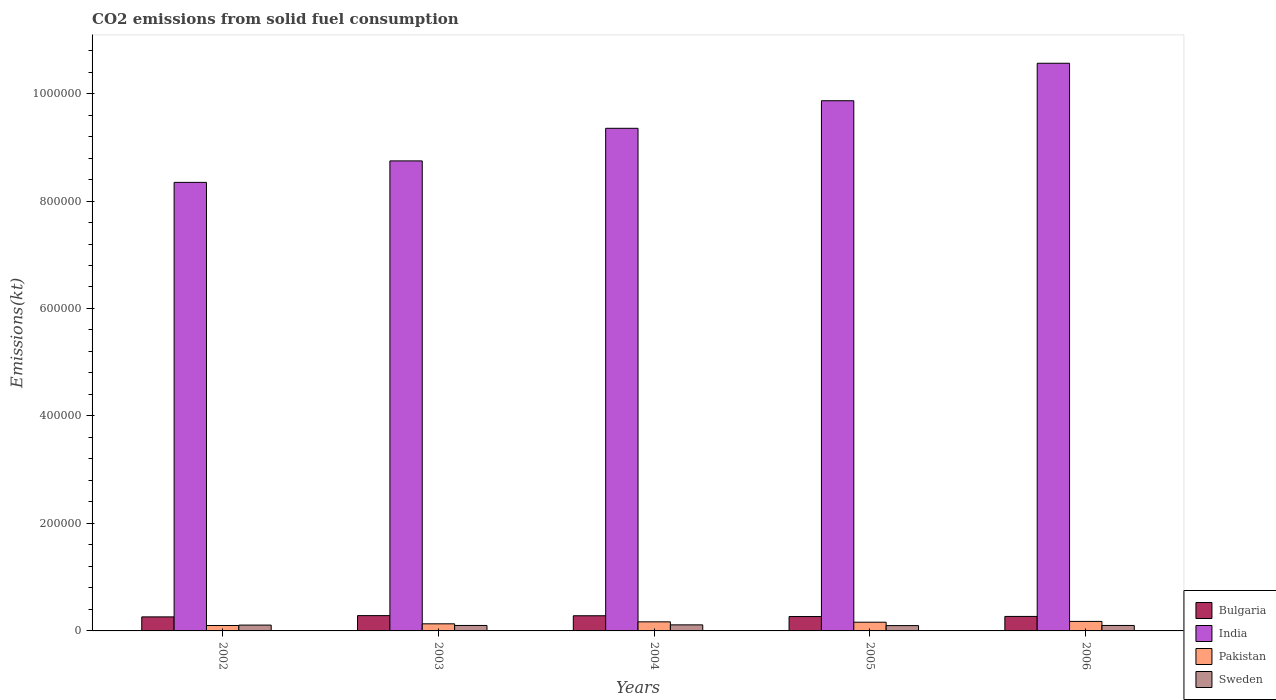How many groups of bars are there?
Make the answer very short. 5. Are the number of bars per tick equal to the number of legend labels?
Ensure brevity in your answer.  Yes. Are the number of bars on each tick of the X-axis equal?
Ensure brevity in your answer.  Yes. How many bars are there on the 4th tick from the left?
Your response must be concise. 4. What is the label of the 4th group of bars from the left?
Your answer should be very brief. 2005. In how many cases, is the number of bars for a given year not equal to the number of legend labels?
Ensure brevity in your answer.  0. What is the amount of CO2 emitted in Sweden in 2002?
Make the answer very short. 1.09e+04. Across all years, what is the maximum amount of CO2 emitted in Pakistan?
Offer a terse response. 1.77e+04. Across all years, what is the minimum amount of CO2 emitted in Pakistan?
Your answer should be compact. 1.01e+04. In which year was the amount of CO2 emitted in Sweden maximum?
Provide a short and direct response. 2004. In which year was the amount of CO2 emitted in India minimum?
Provide a short and direct response. 2002. What is the total amount of CO2 emitted in India in the graph?
Your answer should be compact. 4.69e+06. What is the difference between the amount of CO2 emitted in Sweden in 2005 and that in 2006?
Make the answer very short. -256.69. What is the difference between the amount of CO2 emitted in India in 2003 and the amount of CO2 emitted in Bulgaria in 2005?
Your response must be concise. 8.48e+05. What is the average amount of CO2 emitted in India per year?
Provide a short and direct response. 9.38e+05. In the year 2002, what is the difference between the amount of CO2 emitted in Pakistan and amount of CO2 emitted in Bulgaria?
Ensure brevity in your answer.  -1.60e+04. In how many years, is the amount of CO2 emitted in Pakistan greater than 920000 kt?
Your answer should be compact. 0. What is the ratio of the amount of CO2 emitted in India in 2004 to that in 2006?
Offer a terse response. 0.89. Is the amount of CO2 emitted in Sweden in 2002 less than that in 2003?
Your answer should be compact. No. Is the difference between the amount of CO2 emitted in Pakistan in 2003 and 2006 greater than the difference between the amount of CO2 emitted in Bulgaria in 2003 and 2006?
Provide a short and direct response. No. What is the difference between the highest and the second highest amount of CO2 emitted in Bulgaria?
Keep it short and to the point. 260.36. What is the difference between the highest and the lowest amount of CO2 emitted in Pakistan?
Your answer should be very brief. 7616.36. In how many years, is the amount of CO2 emitted in Bulgaria greater than the average amount of CO2 emitted in Bulgaria taken over all years?
Your answer should be compact. 2. What does the 1st bar from the right in 2006 represents?
Make the answer very short. Sweden. Is it the case that in every year, the sum of the amount of CO2 emitted in Pakistan and amount of CO2 emitted in India is greater than the amount of CO2 emitted in Sweden?
Give a very brief answer. Yes. Are all the bars in the graph horizontal?
Your response must be concise. No. What is the difference between two consecutive major ticks on the Y-axis?
Your response must be concise. 2.00e+05. Does the graph contain grids?
Offer a very short reply. No. How many legend labels are there?
Make the answer very short. 4. What is the title of the graph?
Your response must be concise. CO2 emissions from solid fuel consumption. What is the label or title of the X-axis?
Your answer should be compact. Years. What is the label or title of the Y-axis?
Give a very brief answer. Emissions(kt). What is the Emissions(kt) in Bulgaria in 2002?
Provide a short and direct response. 2.61e+04. What is the Emissions(kt) of India in 2002?
Provide a short and direct response. 8.35e+05. What is the Emissions(kt) of Pakistan in 2002?
Give a very brief answer. 1.01e+04. What is the Emissions(kt) of Sweden in 2002?
Keep it short and to the point. 1.09e+04. What is the Emissions(kt) in Bulgaria in 2003?
Make the answer very short. 2.85e+04. What is the Emissions(kt) in India in 2003?
Keep it short and to the point. 8.75e+05. What is the Emissions(kt) in Pakistan in 2003?
Provide a succinct answer. 1.32e+04. What is the Emissions(kt) in Sweden in 2003?
Keep it short and to the point. 1.02e+04. What is the Emissions(kt) of Bulgaria in 2004?
Provide a succinct answer. 2.82e+04. What is the Emissions(kt) in India in 2004?
Keep it short and to the point. 9.35e+05. What is the Emissions(kt) in Pakistan in 2004?
Give a very brief answer. 1.69e+04. What is the Emissions(kt) of Sweden in 2004?
Provide a succinct answer. 1.13e+04. What is the Emissions(kt) in Bulgaria in 2005?
Provide a short and direct response. 2.68e+04. What is the Emissions(kt) of India in 2005?
Keep it short and to the point. 9.87e+05. What is the Emissions(kt) of Pakistan in 2005?
Offer a very short reply. 1.62e+04. What is the Emissions(kt) in Sweden in 2005?
Provide a short and direct response. 9900.9. What is the Emissions(kt) in Bulgaria in 2006?
Give a very brief answer. 2.70e+04. What is the Emissions(kt) of India in 2006?
Your answer should be compact. 1.06e+06. What is the Emissions(kt) of Pakistan in 2006?
Ensure brevity in your answer.  1.77e+04. What is the Emissions(kt) in Sweden in 2006?
Give a very brief answer. 1.02e+04. Across all years, what is the maximum Emissions(kt) in Bulgaria?
Offer a very short reply. 2.85e+04. Across all years, what is the maximum Emissions(kt) of India?
Your answer should be compact. 1.06e+06. Across all years, what is the maximum Emissions(kt) of Pakistan?
Provide a short and direct response. 1.77e+04. Across all years, what is the maximum Emissions(kt) of Sweden?
Offer a terse response. 1.13e+04. Across all years, what is the minimum Emissions(kt) of Bulgaria?
Offer a very short reply. 2.61e+04. Across all years, what is the minimum Emissions(kt) of India?
Your answer should be compact. 8.35e+05. Across all years, what is the minimum Emissions(kt) in Pakistan?
Your answer should be very brief. 1.01e+04. Across all years, what is the minimum Emissions(kt) of Sweden?
Provide a succinct answer. 9900.9. What is the total Emissions(kt) of Bulgaria in the graph?
Offer a very short reply. 1.37e+05. What is the total Emissions(kt) in India in the graph?
Offer a terse response. 4.69e+06. What is the total Emissions(kt) of Pakistan in the graph?
Keep it short and to the point. 7.41e+04. What is the total Emissions(kt) in Sweden in the graph?
Your response must be concise. 5.24e+04. What is the difference between the Emissions(kt) of Bulgaria in 2002 and that in 2003?
Your answer should be compact. -2368.88. What is the difference between the Emissions(kt) in India in 2002 and that in 2003?
Provide a short and direct response. -4.00e+04. What is the difference between the Emissions(kt) in Pakistan in 2002 and that in 2003?
Keep it short and to the point. -3116.95. What is the difference between the Emissions(kt) in Sweden in 2002 and that in 2003?
Your response must be concise. 696.73. What is the difference between the Emissions(kt) in Bulgaria in 2002 and that in 2004?
Give a very brief answer. -2108.53. What is the difference between the Emissions(kt) in India in 2002 and that in 2004?
Offer a very short reply. -1.01e+05. What is the difference between the Emissions(kt) in Pakistan in 2002 and that in 2004?
Provide a short and direct response. -6831.62. What is the difference between the Emissions(kt) in Sweden in 2002 and that in 2004?
Offer a terse response. -410.7. What is the difference between the Emissions(kt) in Bulgaria in 2002 and that in 2005?
Make the answer very short. -634.39. What is the difference between the Emissions(kt) of India in 2002 and that in 2005?
Keep it short and to the point. -1.52e+05. What is the difference between the Emissions(kt) of Pakistan in 2002 and that in 2005?
Ensure brevity in your answer.  -6116.56. What is the difference between the Emissions(kt) of Sweden in 2002 and that in 2005?
Offer a terse response. 960.75. What is the difference between the Emissions(kt) in Bulgaria in 2002 and that in 2006?
Offer a very short reply. -839.74. What is the difference between the Emissions(kt) of India in 2002 and that in 2006?
Provide a succinct answer. -2.22e+05. What is the difference between the Emissions(kt) in Pakistan in 2002 and that in 2006?
Offer a very short reply. -7616.36. What is the difference between the Emissions(kt) of Sweden in 2002 and that in 2006?
Ensure brevity in your answer.  704.06. What is the difference between the Emissions(kt) in Bulgaria in 2003 and that in 2004?
Make the answer very short. 260.36. What is the difference between the Emissions(kt) of India in 2003 and that in 2004?
Ensure brevity in your answer.  -6.06e+04. What is the difference between the Emissions(kt) of Pakistan in 2003 and that in 2004?
Keep it short and to the point. -3714.67. What is the difference between the Emissions(kt) of Sweden in 2003 and that in 2004?
Offer a terse response. -1107.43. What is the difference between the Emissions(kt) of Bulgaria in 2003 and that in 2005?
Offer a very short reply. 1734.49. What is the difference between the Emissions(kt) of India in 2003 and that in 2005?
Your answer should be compact. -1.12e+05. What is the difference between the Emissions(kt) in Pakistan in 2003 and that in 2005?
Your answer should be very brief. -2999.61. What is the difference between the Emissions(kt) in Sweden in 2003 and that in 2005?
Keep it short and to the point. 264.02. What is the difference between the Emissions(kt) of Bulgaria in 2003 and that in 2006?
Keep it short and to the point. 1529.14. What is the difference between the Emissions(kt) in India in 2003 and that in 2006?
Keep it short and to the point. -1.82e+05. What is the difference between the Emissions(kt) in Pakistan in 2003 and that in 2006?
Provide a succinct answer. -4499.41. What is the difference between the Emissions(kt) in Sweden in 2003 and that in 2006?
Keep it short and to the point. 7.33. What is the difference between the Emissions(kt) of Bulgaria in 2004 and that in 2005?
Make the answer very short. 1474.13. What is the difference between the Emissions(kt) of India in 2004 and that in 2005?
Provide a short and direct response. -5.13e+04. What is the difference between the Emissions(kt) in Pakistan in 2004 and that in 2005?
Offer a very short reply. 715.07. What is the difference between the Emissions(kt) of Sweden in 2004 and that in 2005?
Offer a very short reply. 1371.46. What is the difference between the Emissions(kt) of Bulgaria in 2004 and that in 2006?
Ensure brevity in your answer.  1268.78. What is the difference between the Emissions(kt) in India in 2004 and that in 2006?
Provide a short and direct response. -1.21e+05. What is the difference between the Emissions(kt) in Pakistan in 2004 and that in 2006?
Offer a terse response. -784.74. What is the difference between the Emissions(kt) in Sweden in 2004 and that in 2006?
Ensure brevity in your answer.  1114.77. What is the difference between the Emissions(kt) in Bulgaria in 2005 and that in 2006?
Give a very brief answer. -205.35. What is the difference between the Emissions(kt) in India in 2005 and that in 2006?
Offer a very short reply. -6.97e+04. What is the difference between the Emissions(kt) in Pakistan in 2005 and that in 2006?
Make the answer very short. -1499.8. What is the difference between the Emissions(kt) of Sweden in 2005 and that in 2006?
Give a very brief answer. -256.69. What is the difference between the Emissions(kt) in Bulgaria in 2002 and the Emissions(kt) in India in 2003?
Provide a succinct answer. -8.49e+05. What is the difference between the Emissions(kt) of Bulgaria in 2002 and the Emissions(kt) of Pakistan in 2003?
Provide a succinct answer. 1.29e+04. What is the difference between the Emissions(kt) of Bulgaria in 2002 and the Emissions(kt) of Sweden in 2003?
Your answer should be compact. 1.60e+04. What is the difference between the Emissions(kt) in India in 2002 and the Emissions(kt) in Pakistan in 2003?
Your answer should be compact. 8.21e+05. What is the difference between the Emissions(kt) of India in 2002 and the Emissions(kt) of Sweden in 2003?
Your response must be concise. 8.25e+05. What is the difference between the Emissions(kt) of Pakistan in 2002 and the Emissions(kt) of Sweden in 2003?
Offer a terse response. -77.01. What is the difference between the Emissions(kt) in Bulgaria in 2002 and the Emissions(kt) in India in 2004?
Your answer should be very brief. -9.09e+05. What is the difference between the Emissions(kt) in Bulgaria in 2002 and the Emissions(kt) in Pakistan in 2004?
Your answer should be compact. 9200.5. What is the difference between the Emissions(kt) in Bulgaria in 2002 and the Emissions(kt) in Sweden in 2004?
Your answer should be compact. 1.48e+04. What is the difference between the Emissions(kt) in India in 2002 and the Emissions(kt) in Pakistan in 2004?
Give a very brief answer. 8.18e+05. What is the difference between the Emissions(kt) in India in 2002 and the Emissions(kt) in Sweden in 2004?
Ensure brevity in your answer.  8.23e+05. What is the difference between the Emissions(kt) of Pakistan in 2002 and the Emissions(kt) of Sweden in 2004?
Give a very brief answer. -1184.44. What is the difference between the Emissions(kt) of Bulgaria in 2002 and the Emissions(kt) of India in 2005?
Your answer should be very brief. -9.61e+05. What is the difference between the Emissions(kt) of Bulgaria in 2002 and the Emissions(kt) of Pakistan in 2005?
Offer a terse response. 9915.57. What is the difference between the Emissions(kt) in Bulgaria in 2002 and the Emissions(kt) in Sweden in 2005?
Offer a very short reply. 1.62e+04. What is the difference between the Emissions(kt) of India in 2002 and the Emissions(kt) of Pakistan in 2005?
Your response must be concise. 8.18e+05. What is the difference between the Emissions(kt) in India in 2002 and the Emissions(kt) in Sweden in 2005?
Your answer should be very brief. 8.25e+05. What is the difference between the Emissions(kt) in Pakistan in 2002 and the Emissions(kt) in Sweden in 2005?
Offer a terse response. 187.02. What is the difference between the Emissions(kt) of Bulgaria in 2002 and the Emissions(kt) of India in 2006?
Give a very brief answer. -1.03e+06. What is the difference between the Emissions(kt) of Bulgaria in 2002 and the Emissions(kt) of Pakistan in 2006?
Keep it short and to the point. 8415.76. What is the difference between the Emissions(kt) of Bulgaria in 2002 and the Emissions(kt) of Sweden in 2006?
Your answer should be compact. 1.60e+04. What is the difference between the Emissions(kt) of India in 2002 and the Emissions(kt) of Pakistan in 2006?
Your answer should be compact. 8.17e+05. What is the difference between the Emissions(kt) of India in 2002 and the Emissions(kt) of Sweden in 2006?
Provide a short and direct response. 8.25e+05. What is the difference between the Emissions(kt) of Pakistan in 2002 and the Emissions(kt) of Sweden in 2006?
Provide a short and direct response. -69.67. What is the difference between the Emissions(kt) of Bulgaria in 2003 and the Emissions(kt) of India in 2004?
Ensure brevity in your answer.  -9.07e+05. What is the difference between the Emissions(kt) of Bulgaria in 2003 and the Emissions(kt) of Pakistan in 2004?
Give a very brief answer. 1.16e+04. What is the difference between the Emissions(kt) in Bulgaria in 2003 and the Emissions(kt) in Sweden in 2004?
Provide a succinct answer. 1.72e+04. What is the difference between the Emissions(kt) in India in 2003 and the Emissions(kt) in Pakistan in 2004?
Offer a very short reply. 8.58e+05. What is the difference between the Emissions(kt) of India in 2003 and the Emissions(kt) of Sweden in 2004?
Your answer should be very brief. 8.63e+05. What is the difference between the Emissions(kt) in Pakistan in 2003 and the Emissions(kt) in Sweden in 2004?
Your answer should be very brief. 1932.51. What is the difference between the Emissions(kt) of Bulgaria in 2003 and the Emissions(kt) of India in 2005?
Make the answer very short. -9.58e+05. What is the difference between the Emissions(kt) in Bulgaria in 2003 and the Emissions(kt) in Pakistan in 2005?
Offer a terse response. 1.23e+04. What is the difference between the Emissions(kt) in Bulgaria in 2003 and the Emissions(kt) in Sweden in 2005?
Give a very brief answer. 1.86e+04. What is the difference between the Emissions(kt) of India in 2003 and the Emissions(kt) of Pakistan in 2005?
Keep it short and to the point. 8.58e+05. What is the difference between the Emissions(kt) of India in 2003 and the Emissions(kt) of Sweden in 2005?
Keep it short and to the point. 8.65e+05. What is the difference between the Emissions(kt) in Pakistan in 2003 and the Emissions(kt) in Sweden in 2005?
Offer a terse response. 3303.97. What is the difference between the Emissions(kt) in Bulgaria in 2003 and the Emissions(kt) in India in 2006?
Give a very brief answer. -1.03e+06. What is the difference between the Emissions(kt) in Bulgaria in 2003 and the Emissions(kt) in Pakistan in 2006?
Offer a very short reply. 1.08e+04. What is the difference between the Emissions(kt) in Bulgaria in 2003 and the Emissions(kt) in Sweden in 2006?
Ensure brevity in your answer.  1.83e+04. What is the difference between the Emissions(kt) in India in 2003 and the Emissions(kt) in Pakistan in 2006?
Offer a very short reply. 8.57e+05. What is the difference between the Emissions(kt) in India in 2003 and the Emissions(kt) in Sweden in 2006?
Give a very brief answer. 8.65e+05. What is the difference between the Emissions(kt) of Pakistan in 2003 and the Emissions(kt) of Sweden in 2006?
Offer a very short reply. 3047.28. What is the difference between the Emissions(kt) in Bulgaria in 2004 and the Emissions(kt) in India in 2005?
Keep it short and to the point. -9.58e+05. What is the difference between the Emissions(kt) in Bulgaria in 2004 and the Emissions(kt) in Pakistan in 2005?
Your response must be concise. 1.20e+04. What is the difference between the Emissions(kt) in Bulgaria in 2004 and the Emissions(kt) in Sweden in 2005?
Make the answer very short. 1.83e+04. What is the difference between the Emissions(kt) of India in 2004 and the Emissions(kt) of Pakistan in 2005?
Offer a terse response. 9.19e+05. What is the difference between the Emissions(kt) of India in 2004 and the Emissions(kt) of Sweden in 2005?
Offer a very short reply. 9.25e+05. What is the difference between the Emissions(kt) of Pakistan in 2004 and the Emissions(kt) of Sweden in 2005?
Make the answer very short. 7018.64. What is the difference between the Emissions(kt) of Bulgaria in 2004 and the Emissions(kt) of India in 2006?
Your answer should be very brief. -1.03e+06. What is the difference between the Emissions(kt) in Bulgaria in 2004 and the Emissions(kt) in Pakistan in 2006?
Offer a very short reply. 1.05e+04. What is the difference between the Emissions(kt) of Bulgaria in 2004 and the Emissions(kt) of Sweden in 2006?
Make the answer very short. 1.81e+04. What is the difference between the Emissions(kt) in India in 2004 and the Emissions(kt) in Pakistan in 2006?
Provide a short and direct response. 9.18e+05. What is the difference between the Emissions(kt) in India in 2004 and the Emissions(kt) in Sweden in 2006?
Ensure brevity in your answer.  9.25e+05. What is the difference between the Emissions(kt) in Pakistan in 2004 and the Emissions(kt) in Sweden in 2006?
Provide a short and direct response. 6761.95. What is the difference between the Emissions(kt) in Bulgaria in 2005 and the Emissions(kt) in India in 2006?
Give a very brief answer. -1.03e+06. What is the difference between the Emissions(kt) in Bulgaria in 2005 and the Emissions(kt) in Pakistan in 2006?
Provide a short and direct response. 9050.16. What is the difference between the Emissions(kt) of Bulgaria in 2005 and the Emissions(kt) of Sweden in 2006?
Keep it short and to the point. 1.66e+04. What is the difference between the Emissions(kt) of India in 2005 and the Emissions(kt) of Pakistan in 2006?
Offer a terse response. 9.69e+05. What is the difference between the Emissions(kt) of India in 2005 and the Emissions(kt) of Sweden in 2006?
Provide a short and direct response. 9.76e+05. What is the difference between the Emissions(kt) of Pakistan in 2005 and the Emissions(kt) of Sweden in 2006?
Offer a very short reply. 6046.88. What is the average Emissions(kt) in Bulgaria per year?
Offer a very short reply. 2.73e+04. What is the average Emissions(kt) in India per year?
Offer a very short reply. 9.38e+05. What is the average Emissions(kt) in Pakistan per year?
Your response must be concise. 1.48e+04. What is the average Emissions(kt) in Sweden per year?
Offer a terse response. 1.05e+04. In the year 2002, what is the difference between the Emissions(kt) in Bulgaria and Emissions(kt) in India?
Your answer should be very brief. -8.09e+05. In the year 2002, what is the difference between the Emissions(kt) in Bulgaria and Emissions(kt) in Pakistan?
Ensure brevity in your answer.  1.60e+04. In the year 2002, what is the difference between the Emissions(kt) in Bulgaria and Emissions(kt) in Sweden?
Your answer should be very brief. 1.53e+04. In the year 2002, what is the difference between the Emissions(kt) of India and Emissions(kt) of Pakistan?
Provide a succinct answer. 8.25e+05. In the year 2002, what is the difference between the Emissions(kt) of India and Emissions(kt) of Sweden?
Keep it short and to the point. 8.24e+05. In the year 2002, what is the difference between the Emissions(kt) in Pakistan and Emissions(kt) in Sweden?
Your answer should be compact. -773.74. In the year 2003, what is the difference between the Emissions(kt) of Bulgaria and Emissions(kt) of India?
Provide a short and direct response. -8.46e+05. In the year 2003, what is the difference between the Emissions(kt) in Bulgaria and Emissions(kt) in Pakistan?
Ensure brevity in your answer.  1.53e+04. In the year 2003, what is the difference between the Emissions(kt) of Bulgaria and Emissions(kt) of Sweden?
Give a very brief answer. 1.83e+04. In the year 2003, what is the difference between the Emissions(kt) of India and Emissions(kt) of Pakistan?
Your answer should be compact. 8.61e+05. In the year 2003, what is the difference between the Emissions(kt) in India and Emissions(kt) in Sweden?
Give a very brief answer. 8.64e+05. In the year 2003, what is the difference between the Emissions(kt) of Pakistan and Emissions(kt) of Sweden?
Your answer should be very brief. 3039.94. In the year 2004, what is the difference between the Emissions(kt) in Bulgaria and Emissions(kt) in India?
Provide a short and direct response. -9.07e+05. In the year 2004, what is the difference between the Emissions(kt) in Bulgaria and Emissions(kt) in Pakistan?
Offer a terse response. 1.13e+04. In the year 2004, what is the difference between the Emissions(kt) of Bulgaria and Emissions(kt) of Sweden?
Make the answer very short. 1.70e+04. In the year 2004, what is the difference between the Emissions(kt) in India and Emissions(kt) in Pakistan?
Your answer should be compact. 9.18e+05. In the year 2004, what is the difference between the Emissions(kt) in India and Emissions(kt) in Sweden?
Make the answer very short. 9.24e+05. In the year 2004, what is the difference between the Emissions(kt) in Pakistan and Emissions(kt) in Sweden?
Offer a very short reply. 5647.18. In the year 2005, what is the difference between the Emissions(kt) of Bulgaria and Emissions(kt) of India?
Give a very brief answer. -9.60e+05. In the year 2005, what is the difference between the Emissions(kt) in Bulgaria and Emissions(kt) in Pakistan?
Offer a terse response. 1.05e+04. In the year 2005, what is the difference between the Emissions(kt) in Bulgaria and Emissions(kt) in Sweden?
Keep it short and to the point. 1.69e+04. In the year 2005, what is the difference between the Emissions(kt) of India and Emissions(kt) of Pakistan?
Your response must be concise. 9.70e+05. In the year 2005, what is the difference between the Emissions(kt) of India and Emissions(kt) of Sweden?
Provide a succinct answer. 9.77e+05. In the year 2005, what is the difference between the Emissions(kt) in Pakistan and Emissions(kt) in Sweden?
Your answer should be very brief. 6303.57. In the year 2006, what is the difference between the Emissions(kt) in Bulgaria and Emissions(kt) in India?
Provide a succinct answer. -1.03e+06. In the year 2006, what is the difference between the Emissions(kt) in Bulgaria and Emissions(kt) in Pakistan?
Ensure brevity in your answer.  9255.51. In the year 2006, what is the difference between the Emissions(kt) of Bulgaria and Emissions(kt) of Sweden?
Provide a succinct answer. 1.68e+04. In the year 2006, what is the difference between the Emissions(kt) of India and Emissions(kt) of Pakistan?
Ensure brevity in your answer.  1.04e+06. In the year 2006, what is the difference between the Emissions(kt) in India and Emissions(kt) in Sweden?
Your answer should be very brief. 1.05e+06. In the year 2006, what is the difference between the Emissions(kt) in Pakistan and Emissions(kt) in Sweden?
Provide a short and direct response. 7546.69. What is the ratio of the Emissions(kt) of Bulgaria in 2002 to that in 2003?
Give a very brief answer. 0.92. What is the ratio of the Emissions(kt) in India in 2002 to that in 2003?
Provide a succinct answer. 0.95. What is the ratio of the Emissions(kt) in Pakistan in 2002 to that in 2003?
Offer a very short reply. 0.76. What is the ratio of the Emissions(kt) in Sweden in 2002 to that in 2003?
Keep it short and to the point. 1.07. What is the ratio of the Emissions(kt) of Bulgaria in 2002 to that in 2004?
Offer a very short reply. 0.93. What is the ratio of the Emissions(kt) in India in 2002 to that in 2004?
Provide a succinct answer. 0.89. What is the ratio of the Emissions(kt) of Pakistan in 2002 to that in 2004?
Offer a terse response. 0.6. What is the ratio of the Emissions(kt) in Sweden in 2002 to that in 2004?
Your answer should be compact. 0.96. What is the ratio of the Emissions(kt) of Bulgaria in 2002 to that in 2005?
Give a very brief answer. 0.98. What is the ratio of the Emissions(kt) of India in 2002 to that in 2005?
Offer a terse response. 0.85. What is the ratio of the Emissions(kt) in Pakistan in 2002 to that in 2005?
Your answer should be very brief. 0.62. What is the ratio of the Emissions(kt) in Sweden in 2002 to that in 2005?
Give a very brief answer. 1.1. What is the ratio of the Emissions(kt) of Bulgaria in 2002 to that in 2006?
Your answer should be very brief. 0.97. What is the ratio of the Emissions(kt) in India in 2002 to that in 2006?
Offer a terse response. 0.79. What is the ratio of the Emissions(kt) of Pakistan in 2002 to that in 2006?
Your answer should be compact. 0.57. What is the ratio of the Emissions(kt) of Sweden in 2002 to that in 2006?
Keep it short and to the point. 1.07. What is the ratio of the Emissions(kt) in Bulgaria in 2003 to that in 2004?
Your answer should be compact. 1.01. What is the ratio of the Emissions(kt) in India in 2003 to that in 2004?
Provide a succinct answer. 0.94. What is the ratio of the Emissions(kt) of Pakistan in 2003 to that in 2004?
Your response must be concise. 0.78. What is the ratio of the Emissions(kt) of Sweden in 2003 to that in 2004?
Offer a terse response. 0.9. What is the ratio of the Emissions(kt) in Bulgaria in 2003 to that in 2005?
Your response must be concise. 1.06. What is the ratio of the Emissions(kt) of India in 2003 to that in 2005?
Keep it short and to the point. 0.89. What is the ratio of the Emissions(kt) of Pakistan in 2003 to that in 2005?
Provide a short and direct response. 0.81. What is the ratio of the Emissions(kt) of Sweden in 2003 to that in 2005?
Your answer should be very brief. 1.03. What is the ratio of the Emissions(kt) in Bulgaria in 2003 to that in 2006?
Provide a succinct answer. 1.06. What is the ratio of the Emissions(kt) in India in 2003 to that in 2006?
Your response must be concise. 0.83. What is the ratio of the Emissions(kt) of Pakistan in 2003 to that in 2006?
Give a very brief answer. 0.75. What is the ratio of the Emissions(kt) in Sweden in 2003 to that in 2006?
Provide a short and direct response. 1. What is the ratio of the Emissions(kt) in Bulgaria in 2004 to that in 2005?
Your response must be concise. 1.06. What is the ratio of the Emissions(kt) in India in 2004 to that in 2005?
Your answer should be very brief. 0.95. What is the ratio of the Emissions(kt) in Pakistan in 2004 to that in 2005?
Provide a succinct answer. 1.04. What is the ratio of the Emissions(kt) of Sweden in 2004 to that in 2005?
Offer a terse response. 1.14. What is the ratio of the Emissions(kt) in Bulgaria in 2004 to that in 2006?
Offer a very short reply. 1.05. What is the ratio of the Emissions(kt) of India in 2004 to that in 2006?
Keep it short and to the point. 0.89. What is the ratio of the Emissions(kt) of Pakistan in 2004 to that in 2006?
Your response must be concise. 0.96. What is the ratio of the Emissions(kt) in Sweden in 2004 to that in 2006?
Give a very brief answer. 1.11. What is the ratio of the Emissions(kt) in Bulgaria in 2005 to that in 2006?
Give a very brief answer. 0.99. What is the ratio of the Emissions(kt) of India in 2005 to that in 2006?
Ensure brevity in your answer.  0.93. What is the ratio of the Emissions(kt) of Pakistan in 2005 to that in 2006?
Offer a terse response. 0.92. What is the ratio of the Emissions(kt) in Sweden in 2005 to that in 2006?
Give a very brief answer. 0.97. What is the difference between the highest and the second highest Emissions(kt) in Bulgaria?
Your response must be concise. 260.36. What is the difference between the highest and the second highest Emissions(kt) of India?
Your response must be concise. 6.97e+04. What is the difference between the highest and the second highest Emissions(kt) in Pakistan?
Your response must be concise. 784.74. What is the difference between the highest and the second highest Emissions(kt) in Sweden?
Ensure brevity in your answer.  410.7. What is the difference between the highest and the lowest Emissions(kt) of Bulgaria?
Provide a succinct answer. 2368.88. What is the difference between the highest and the lowest Emissions(kt) of India?
Ensure brevity in your answer.  2.22e+05. What is the difference between the highest and the lowest Emissions(kt) of Pakistan?
Make the answer very short. 7616.36. What is the difference between the highest and the lowest Emissions(kt) in Sweden?
Provide a succinct answer. 1371.46. 